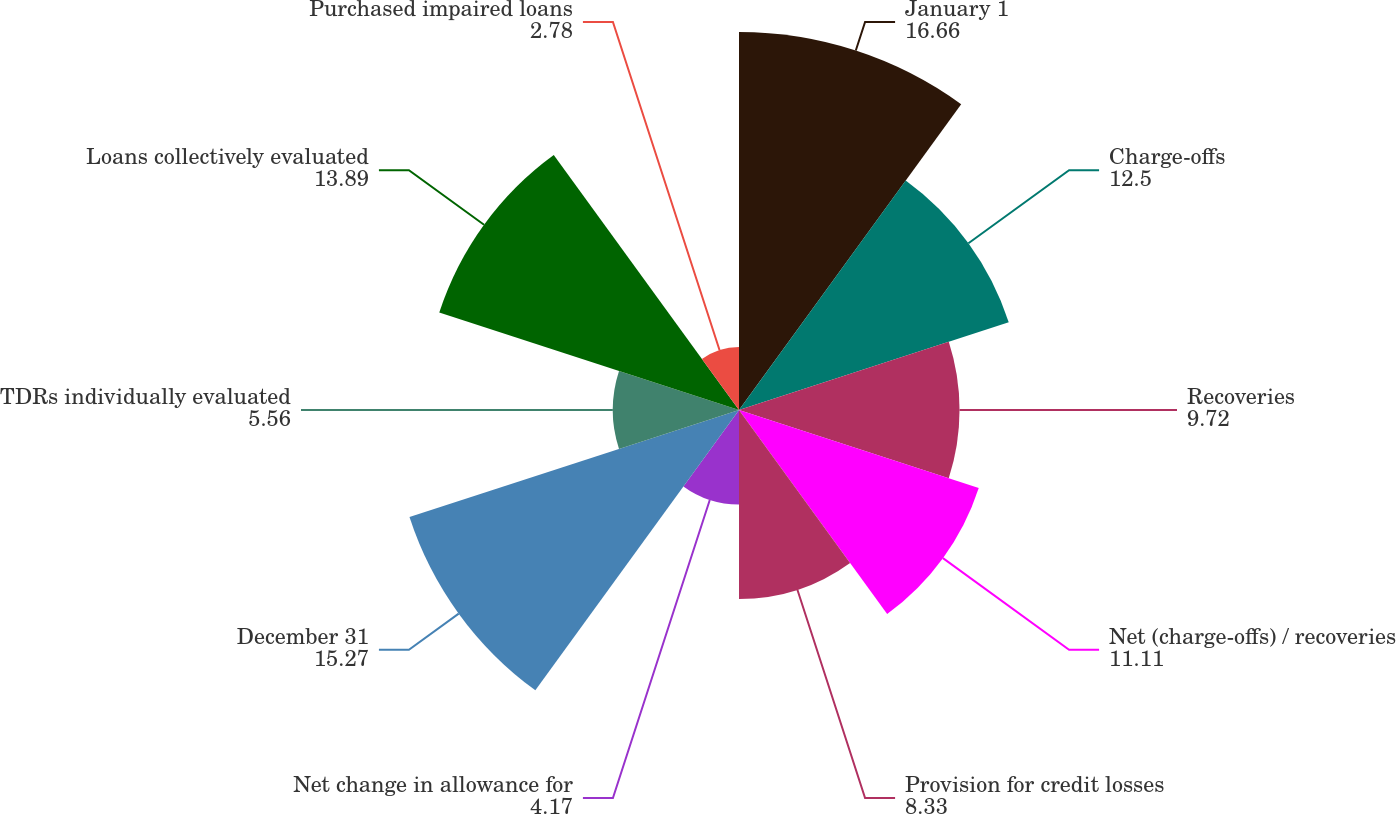Convert chart. <chart><loc_0><loc_0><loc_500><loc_500><pie_chart><fcel>January 1<fcel>Charge-offs<fcel>Recoveries<fcel>Net (charge-offs) / recoveries<fcel>Provision for credit losses<fcel>Net change in allowance for<fcel>December 31<fcel>TDRs individually evaluated<fcel>Loans collectively evaluated<fcel>Purchased impaired loans<nl><fcel>16.66%<fcel>12.5%<fcel>9.72%<fcel>11.11%<fcel>8.33%<fcel>4.17%<fcel>15.27%<fcel>5.56%<fcel>13.89%<fcel>2.78%<nl></chart> 